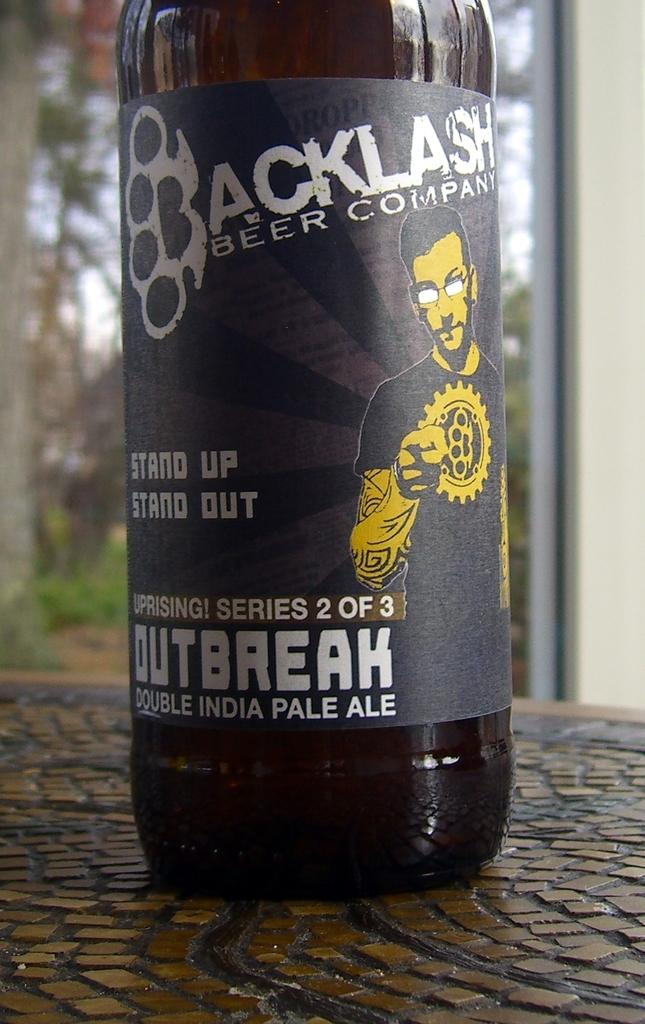<image>
Create a compact narrative representing the image presented. A bottle of Outbreak beer from Backlash Beer Company sits on a table with small, decorative tiles. 